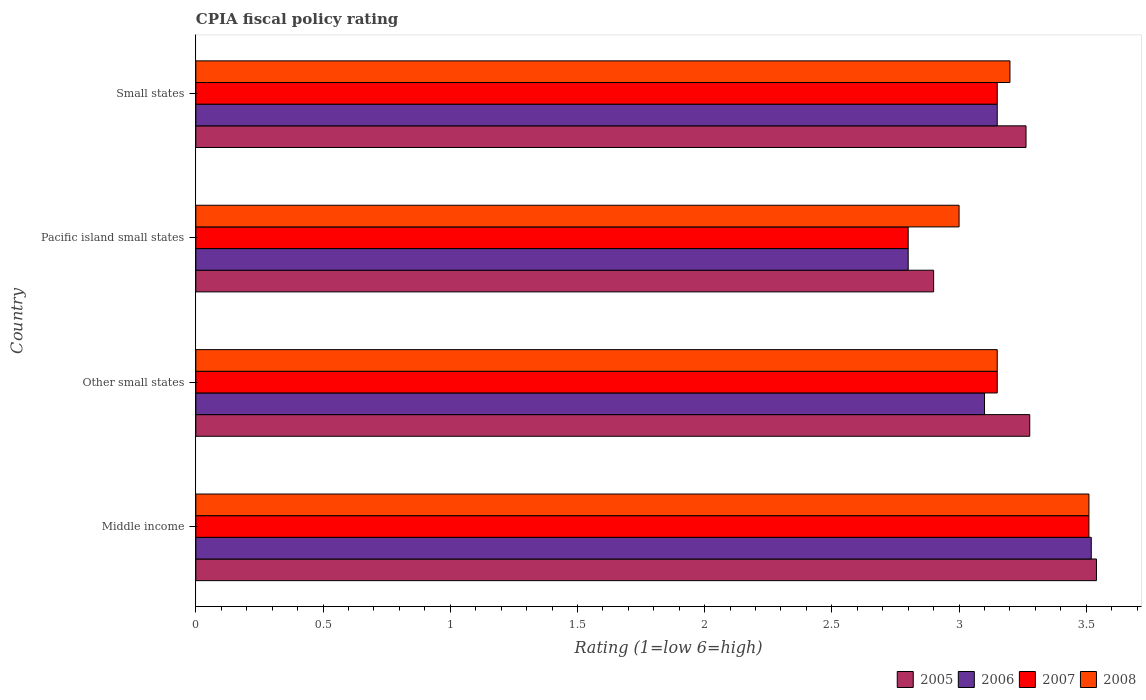How many different coloured bars are there?
Make the answer very short. 4. How many groups of bars are there?
Provide a succinct answer. 4. Are the number of bars per tick equal to the number of legend labels?
Offer a terse response. Yes. How many bars are there on the 2nd tick from the bottom?
Keep it short and to the point. 4. What is the label of the 1st group of bars from the top?
Give a very brief answer. Small states. In how many cases, is the number of bars for a given country not equal to the number of legend labels?
Make the answer very short. 0. Across all countries, what is the maximum CPIA rating in 2005?
Provide a succinct answer. 3.54. Across all countries, what is the minimum CPIA rating in 2007?
Make the answer very short. 2.8. In which country was the CPIA rating in 2007 minimum?
Your answer should be compact. Pacific island small states. What is the total CPIA rating in 2008 in the graph?
Give a very brief answer. 12.86. What is the difference between the CPIA rating in 2007 in Other small states and that in Small states?
Provide a short and direct response. 0. What is the difference between the CPIA rating in 2005 in Pacific island small states and the CPIA rating in 2006 in Other small states?
Your answer should be compact. -0.2. What is the average CPIA rating in 2007 per country?
Provide a succinct answer. 3.15. What is the difference between the CPIA rating in 2008 and CPIA rating in 2007 in Other small states?
Offer a terse response. 0. What is the ratio of the CPIA rating in 2007 in Pacific island small states to that in Small states?
Provide a succinct answer. 0.89. What is the difference between the highest and the second highest CPIA rating in 2006?
Your answer should be compact. 0.37. What is the difference between the highest and the lowest CPIA rating in 2007?
Give a very brief answer. 0.71. Is the sum of the CPIA rating in 2006 in Pacific island small states and Small states greater than the maximum CPIA rating in 2008 across all countries?
Offer a very short reply. Yes. Is it the case that in every country, the sum of the CPIA rating in 2008 and CPIA rating in 2007 is greater than the sum of CPIA rating in 2006 and CPIA rating in 2005?
Provide a succinct answer. No. What does the 2nd bar from the bottom in Middle income represents?
Keep it short and to the point. 2006. Is it the case that in every country, the sum of the CPIA rating in 2006 and CPIA rating in 2008 is greater than the CPIA rating in 2005?
Ensure brevity in your answer.  Yes. How many bars are there?
Your answer should be compact. 16. Are all the bars in the graph horizontal?
Keep it short and to the point. Yes. What is the difference between two consecutive major ticks on the X-axis?
Make the answer very short. 0.5. Does the graph contain any zero values?
Offer a terse response. No. Does the graph contain grids?
Offer a terse response. No. What is the title of the graph?
Provide a succinct answer. CPIA fiscal policy rating. Does "1991" appear as one of the legend labels in the graph?
Your answer should be very brief. No. What is the label or title of the X-axis?
Offer a terse response. Rating (1=low 6=high). What is the Rating (1=low 6=high) in 2005 in Middle income?
Your answer should be very brief. 3.54. What is the Rating (1=low 6=high) of 2006 in Middle income?
Your answer should be very brief. 3.52. What is the Rating (1=low 6=high) of 2007 in Middle income?
Your answer should be very brief. 3.51. What is the Rating (1=low 6=high) in 2008 in Middle income?
Your answer should be very brief. 3.51. What is the Rating (1=low 6=high) of 2005 in Other small states?
Your answer should be very brief. 3.28. What is the Rating (1=low 6=high) of 2006 in Other small states?
Keep it short and to the point. 3.1. What is the Rating (1=low 6=high) in 2007 in Other small states?
Give a very brief answer. 3.15. What is the Rating (1=low 6=high) in 2008 in Other small states?
Provide a succinct answer. 3.15. What is the Rating (1=low 6=high) in 2006 in Pacific island small states?
Offer a terse response. 2.8. What is the Rating (1=low 6=high) of 2005 in Small states?
Offer a terse response. 3.26. What is the Rating (1=low 6=high) in 2006 in Small states?
Give a very brief answer. 3.15. What is the Rating (1=low 6=high) of 2007 in Small states?
Offer a terse response. 3.15. What is the Rating (1=low 6=high) in 2008 in Small states?
Provide a succinct answer. 3.2. Across all countries, what is the maximum Rating (1=low 6=high) of 2005?
Your answer should be very brief. 3.54. Across all countries, what is the maximum Rating (1=low 6=high) of 2006?
Your answer should be very brief. 3.52. Across all countries, what is the maximum Rating (1=low 6=high) of 2007?
Provide a succinct answer. 3.51. Across all countries, what is the maximum Rating (1=low 6=high) of 2008?
Keep it short and to the point. 3.51. Across all countries, what is the minimum Rating (1=low 6=high) of 2005?
Provide a succinct answer. 2.9. Across all countries, what is the minimum Rating (1=low 6=high) of 2007?
Offer a very short reply. 2.8. What is the total Rating (1=low 6=high) in 2005 in the graph?
Provide a short and direct response. 12.98. What is the total Rating (1=low 6=high) of 2006 in the graph?
Your answer should be compact. 12.57. What is the total Rating (1=low 6=high) of 2007 in the graph?
Your answer should be very brief. 12.61. What is the total Rating (1=low 6=high) in 2008 in the graph?
Keep it short and to the point. 12.86. What is the difference between the Rating (1=low 6=high) of 2005 in Middle income and that in Other small states?
Make the answer very short. 0.26. What is the difference between the Rating (1=low 6=high) in 2006 in Middle income and that in Other small states?
Make the answer very short. 0.42. What is the difference between the Rating (1=low 6=high) in 2007 in Middle income and that in Other small states?
Your answer should be very brief. 0.36. What is the difference between the Rating (1=low 6=high) in 2008 in Middle income and that in Other small states?
Offer a terse response. 0.36. What is the difference between the Rating (1=low 6=high) in 2005 in Middle income and that in Pacific island small states?
Keep it short and to the point. 0.64. What is the difference between the Rating (1=low 6=high) in 2006 in Middle income and that in Pacific island small states?
Make the answer very short. 0.72. What is the difference between the Rating (1=low 6=high) in 2007 in Middle income and that in Pacific island small states?
Make the answer very short. 0.71. What is the difference between the Rating (1=low 6=high) in 2008 in Middle income and that in Pacific island small states?
Provide a short and direct response. 0.51. What is the difference between the Rating (1=low 6=high) of 2005 in Middle income and that in Small states?
Your response must be concise. 0.28. What is the difference between the Rating (1=low 6=high) in 2006 in Middle income and that in Small states?
Make the answer very short. 0.37. What is the difference between the Rating (1=low 6=high) in 2007 in Middle income and that in Small states?
Ensure brevity in your answer.  0.36. What is the difference between the Rating (1=low 6=high) in 2008 in Middle income and that in Small states?
Keep it short and to the point. 0.31. What is the difference between the Rating (1=low 6=high) in 2005 in Other small states and that in Pacific island small states?
Your response must be concise. 0.38. What is the difference between the Rating (1=low 6=high) in 2006 in Other small states and that in Pacific island small states?
Offer a terse response. 0.3. What is the difference between the Rating (1=low 6=high) of 2005 in Other small states and that in Small states?
Offer a very short reply. 0.01. What is the difference between the Rating (1=low 6=high) of 2006 in Other small states and that in Small states?
Give a very brief answer. -0.05. What is the difference between the Rating (1=low 6=high) in 2007 in Other small states and that in Small states?
Your response must be concise. 0. What is the difference between the Rating (1=low 6=high) of 2005 in Pacific island small states and that in Small states?
Keep it short and to the point. -0.36. What is the difference between the Rating (1=low 6=high) of 2006 in Pacific island small states and that in Small states?
Ensure brevity in your answer.  -0.35. What is the difference between the Rating (1=low 6=high) of 2007 in Pacific island small states and that in Small states?
Your answer should be compact. -0.35. What is the difference between the Rating (1=low 6=high) of 2005 in Middle income and the Rating (1=low 6=high) of 2006 in Other small states?
Ensure brevity in your answer.  0.44. What is the difference between the Rating (1=low 6=high) of 2005 in Middle income and the Rating (1=low 6=high) of 2007 in Other small states?
Your answer should be very brief. 0.39. What is the difference between the Rating (1=low 6=high) of 2005 in Middle income and the Rating (1=low 6=high) of 2008 in Other small states?
Ensure brevity in your answer.  0.39. What is the difference between the Rating (1=low 6=high) of 2006 in Middle income and the Rating (1=low 6=high) of 2007 in Other small states?
Provide a short and direct response. 0.37. What is the difference between the Rating (1=low 6=high) in 2006 in Middle income and the Rating (1=low 6=high) in 2008 in Other small states?
Offer a terse response. 0.37. What is the difference between the Rating (1=low 6=high) in 2007 in Middle income and the Rating (1=low 6=high) in 2008 in Other small states?
Keep it short and to the point. 0.36. What is the difference between the Rating (1=low 6=high) of 2005 in Middle income and the Rating (1=low 6=high) of 2006 in Pacific island small states?
Ensure brevity in your answer.  0.74. What is the difference between the Rating (1=low 6=high) in 2005 in Middle income and the Rating (1=low 6=high) in 2007 in Pacific island small states?
Provide a short and direct response. 0.74. What is the difference between the Rating (1=low 6=high) of 2005 in Middle income and the Rating (1=low 6=high) of 2008 in Pacific island small states?
Make the answer very short. 0.54. What is the difference between the Rating (1=low 6=high) of 2006 in Middle income and the Rating (1=low 6=high) of 2007 in Pacific island small states?
Provide a succinct answer. 0.72. What is the difference between the Rating (1=low 6=high) of 2006 in Middle income and the Rating (1=low 6=high) of 2008 in Pacific island small states?
Make the answer very short. 0.52. What is the difference between the Rating (1=low 6=high) in 2007 in Middle income and the Rating (1=low 6=high) in 2008 in Pacific island small states?
Your answer should be very brief. 0.51. What is the difference between the Rating (1=low 6=high) in 2005 in Middle income and the Rating (1=low 6=high) in 2006 in Small states?
Give a very brief answer. 0.39. What is the difference between the Rating (1=low 6=high) in 2005 in Middle income and the Rating (1=low 6=high) in 2007 in Small states?
Your answer should be very brief. 0.39. What is the difference between the Rating (1=low 6=high) in 2005 in Middle income and the Rating (1=low 6=high) in 2008 in Small states?
Provide a succinct answer. 0.34. What is the difference between the Rating (1=low 6=high) in 2006 in Middle income and the Rating (1=low 6=high) in 2007 in Small states?
Ensure brevity in your answer.  0.37. What is the difference between the Rating (1=low 6=high) in 2006 in Middle income and the Rating (1=low 6=high) in 2008 in Small states?
Offer a very short reply. 0.32. What is the difference between the Rating (1=low 6=high) in 2007 in Middle income and the Rating (1=low 6=high) in 2008 in Small states?
Provide a short and direct response. 0.31. What is the difference between the Rating (1=low 6=high) in 2005 in Other small states and the Rating (1=low 6=high) in 2006 in Pacific island small states?
Give a very brief answer. 0.48. What is the difference between the Rating (1=low 6=high) in 2005 in Other small states and the Rating (1=low 6=high) in 2007 in Pacific island small states?
Provide a succinct answer. 0.48. What is the difference between the Rating (1=low 6=high) of 2005 in Other small states and the Rating (1=low 6=high) of 2008 in Pacific island small states?
Your answer should be very brief. 0.28. What is the difference between the Rating (1=low 6=high) of 2006 in Other small states and the Rating (1=low 6=high) of 2007 in Pacific island small states?
Ensure brevity in your answer.  0.3. What is the difference between the Rating (1=low 6=high) of 2007 in Other small states and the Rating (1=low 6=high) of 2008 in Pacific island small states?
Keep it short and to the point. 0.15. What is the difference between the Rating (1=low 6=high) of 2005 in Other small states and the Rating (1=low 6=high) of 2006 in Small states?
Provide a short and direct response. 0.13. What is the difference between the Rating (1=low 6=high) of 2005 in Other small states and the Rating (1=low 6=high) of 2007 in Small states?
Keep it short and to the point. 0.13. What is the difference between the Rating (1=low 6=high) of 2005 in Other small states and the Rating (1=low 6=high) of 2008 in Small states?
Keep it short and to the point. 0.08. What is the difference between the Rating (1=low 6=high) of 2006 in Other small states and the Rating (1=low 6=high) of 2007 in Small states?
Keep it short and to the point. -0.05. What is the difference between the Rating (1=low 6=high) in 2006 in Other small states and the Rating (1=low 6=high) in 2008 in Small states?
Your answer should be very brief. -0.1. What is the difference between the Rating (1=low 6=high) in 2007 in Other small states and the Rating (1=low 6=high) in 2008 in Small states?
Keep it short and to the point. -0.05. What is the difference between the Rating (1=low 6=high) of 2005 in Pacific island small states and the Rating (1=low 6=high) of 2008 in Small states?
Offer a very short reply. -0.3. What is the difference between the Rating (1=low 6=high) in 2006 in Pacific island small states and the Rating (1=low 6=high) in 2007 in Small states?
Your response must be concise. -0.35. What is the average Rating (1=low 6=high) of 2005 per country?
Keep it short and to the point. 3.25. What is the average Rating (1=low 6=high) in 2006 per country?
Provide a short and direct response. 3.14. What is the average Rating (1=low 6=high) of 2007 per country?
Give a very brief answer. 3.15. What is the average Rating (1=low 6=high) of 2008 per country?
Ensure brevity in your answer.  3.22. What is the difference between the Rating (1=low 6=high) of 2005 and Rating (1=low 6=high) of 2006 in Middle income?
Provide a short and direct response. 0.02. What is the difference between the Rating (1=low 6=high) of 2005 and Rating (1=low 6=high) of 2007 in Middle income?
Offer a very short reply. 0.03. What is the difference between the Rating (1=low 6=high) in 2005 and Rating (1=low 6=high) in 2008 in Middle income?
Give a very brief answer. 0.03. What is the difference between the Rating (1=low 6=high) in 2006 and Rating (1=low 6=high) in 2007 in Middle income?
Keep it short and to the point. 0.01. What is the difference between the Rating (1=low 6=high) in 2006 and Rating (1=low 6=high) in 2008 in Middle income?
Your response must be concise. 0.01. What is the difference between the Rating (1=low 6=high) in 2007 and Rating (1=low 6=high) in 2008 in Middle income?
Offer a terse response. 0. What is the difference between the Rating (1=low 6=high) of 2005 and Rating (1=low 6=high) of 2006 in Other small states?
Provide a succinct answer. 0.18. What is the difference between the Rating (1=low 6=high) of 2005 and Rating (1=low 6=high) of 2007 in Other small states?
Your answer should be very brief. 0.13. What is the difference between the Rating (1=low 6=high) in 2005 and Rating (1=low 6=high) in 2008 in Other small states?
Your response must be concise. 0.13. What is the difference between the Rating (1=low 6=high) of 2006 and Rating (1=low 6=high) of 2008 in Other small states?
Provide a short and direct response. -0.05. What is the difference between the Rating (1=low 6=high) of 2007 and Rating (1=low 6=high) of 2008 in Other small states?
Ensure brevity in your answer.  0. What is the difference between the Rating (1=low 6=high) in 2005 and Rating (1=low 6=high) in 2008 in Pacific island small states?
Your answer should be very brief. -0.1. What is the difference between the Rating (1=low 6=high) in 2007 and Rating (1=low 6=high) in 2008 in Pacific island small states?
Make the answer very short. -0.2. What is the difference between the Rating (1=low 6=high) in 2005 and Rating (1=low 6=high) in 2006 in Small states?
Your answer should be compact. 0.11. What is the difference between the Rating (1=low 6=high) of 2005 and Rating (1=low 6=high) of 2007 in Small states?
Provide a short and direct response. 0.11. What is the difference between the Rating (1=low 6=high) in 2005 and Rating (1=low 6=high) in 2008 in Small states?
Provide a short and direct response. 0.06. What is the difference between the Rating (1=low 6=high) in 2006 and Rating (1=low 6=high) in 2008 in Small states?
Your answer should be compact. -0.05. What is the difference between the Rating (1=low 6=high) in 2007 and Rating (1=low 6=high) in 2008 in Small states?
Provide a succinct answer. -0.05. What is the ratio of the Rating (1=low 6=high) in 2005 in Middle income to that in Other small states?
Provide a short and direct response. 1.08. What is the ratio of the Rating (1=low 6=high) in 2006 in Middle income to that in Other small states?
Keep it short and to the point. 1.14. What is the ratio of the Rating (1=low 6=high) in 2007 in Middle income to that in Other small states?
Give a very brief answer. 1.11. What is the ratio of the Rating (1=low 6=high) of 2008 in Middle income to that in Other small states?
Make the answer very short. 1.11. What is the ratio of the Rating (1=low 6=high) of 2005 in Middle income to that in Pacific island small states?
Offer a terse response. 1.22. What is the ratio of the Rating (1=low 6=high) of 2006 in Middle income to that in Pacific island small states?
Offer a very short reply. 1.26. What is the ratio of the Rating (1=low 6=high) in 2007 in Middle income to that in Pacific island small states?
Offer a terse response. 1.25. What is the ratio of the Rating (1=low 6=high) in 2008 in Middle income to that in Pacific island small states?
Keep it short and to the point. 1.17. What is the ratio of the Rating (1=low 6=high) of 2005 in Middle income to that in Small states?
Provide a short and direct response. 1.08. What is the ratio of the Rating (1=low 6=high) of 2006 in Middle income to that in Small states?
Your answer should be compact. 1.12. What is the ratio of the Rating (1=low 6=high) of 2007 in Middle income to that in Small states?
Your response must be concise. 1.11. What is the ratio of the Rating (1=low 6=high) in 2008 in Middle income to that in Small states?
Make the answer very short. 1.1. What is the ratio of the Rating (1=low 6=high) of 2005 in Other small states to that in Pacific island small states?
Ensure brevity in your answer.  1.13. What is the ratio of the Rating (1=low 6=high) in 2006 in Other small states to that in Pacific island small states?
Offer a very short reply. 1.11. What is the ratio of the Rating (1=low 6=high) of 2008 in Other small states to that in Pacific island small states?
Your response must be concise. 1.05. What is the ratio of the Rating (1=low 6=high) of 2006 in Other small states to that in Small states?
Keep it short and to the point. 0.98. What is the ratio of the Rating (1=low 6=high) in 2007 in Other small states to that in Small states?
Give a very brief answer. 1. What is the ratio of the Rating (1=low 6=high) in 2008 in Other small states to that in Small states?
Offer a very short reply. 0.98. What is the ratio of the Rating (1=low 6=high) of 2005 in Pacific island small states to that in Small states?
Give a very brief answer. 0.89. What is the ratio of the Rating (1=low 6=high) of 2006 in Pacific island small states to that in Small states?
Give a very brief answer. 0.89. What is the difference between the highest and the second highest Rating (1=low 6=high) of 2005?
Give a very brief answer. 0.26. What is the difference between the highest and the second highest Rating (1=low 6=high) of 2006?
Give a very brief answer. 0.37. What is the difference between the highest and the second highest Rating (1=low 6=high) of 2007?
Provide a short and direct response. 0.36. What is the difference between the highest and the second highest Rating (1=low 6=high) of 2008?
Offer a terse response. 0.31. What is the difference between the highest and the lowest Rating (1=low 6=high) of 2005?
Provide a succinct answer. 0.64. What is the difference between the highest and the lowest Rating (1=low 6=high) of 2006?
Offer a very short reply. 0.72. What is the difference between the highest and the lowest Rating (1=low 6=high) of 2007?
Provide a short and direct response. 0.71. What is the difference between the highest and the lowest Rating (1=low 6=high) of 2008?
Keep it short and to the point. 0.51. 